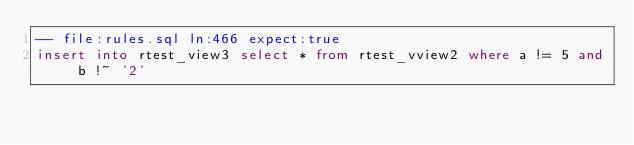<code> <loc_0><loc_0><loc_500><loc_500><_SQL_>-- file:rules.sql ln:466 expect:true
insert into rtest_view3 select * from rtest_vview2 where a != 5 and b !~ '2'
</code> 